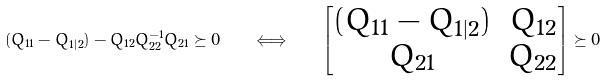<formula> <loc_0><loc_0><loc_500><loc_500>( Q _ { 1 1 } - Q _ { 1 | 2 } ) - Q _ { 1 2 } Q _ { 2 2 } ^ { - 1 } Q _ { 2 1 } \succeq 0 \quad \Longleftrightarrow \quad \begin{bmatrix} ( Q _ { 1 1 } - Q _ { 1 | 2 } ) & Q _ { 1 2 } \\ Q _ { 2 1 } & Q _ { 2 2 } \end{bmatrix} \succeq 0</formula> 